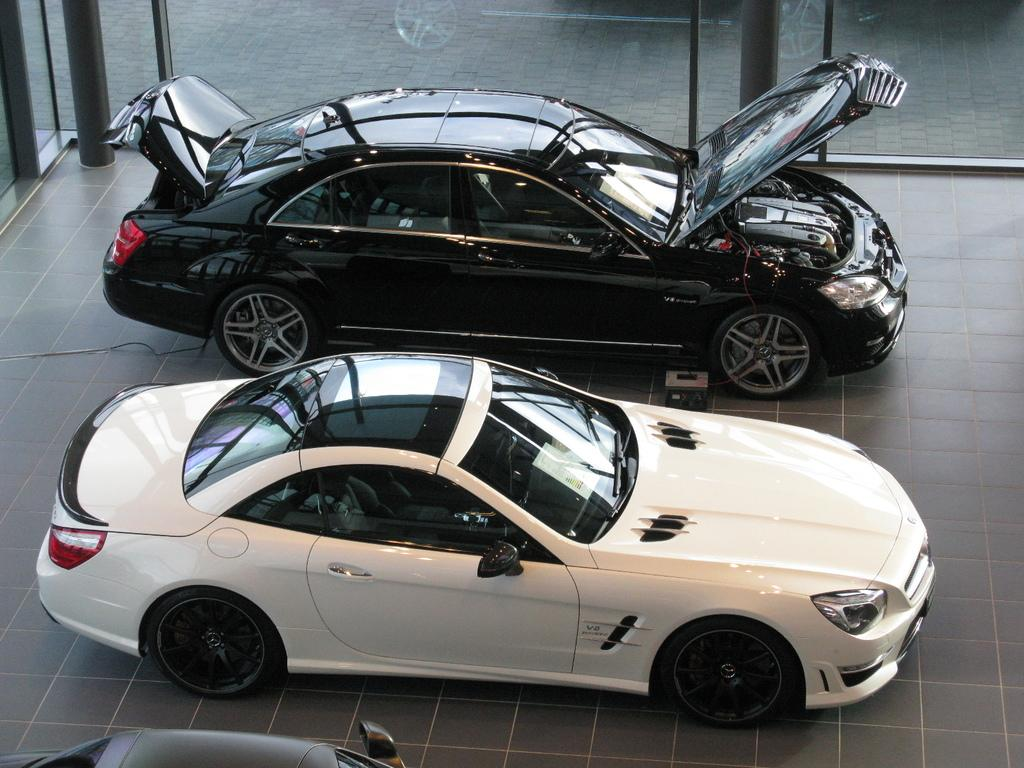What types of objects are present in the image? There are vehicles in the image. Can you describe the floor in the image? The floor appears to be tiled. What type of walls can be seen in the image? There are glass walls in the image. Are there any architectural features visible in the image? Yes, there are pillars in the image. What type of yam is being used to decorate the pillars in the image? There is no yam present in the image, and the pillars are not being decorated with any yam. 